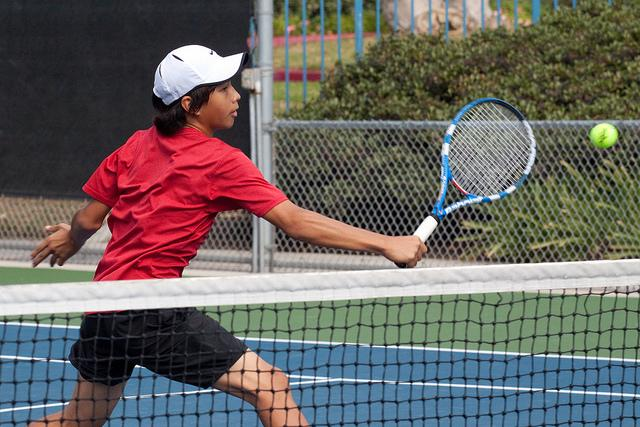Why is the boy reaching for the ball?

Choices:
A) to throw
B) to show
C) to hit
D) to catch to hit 